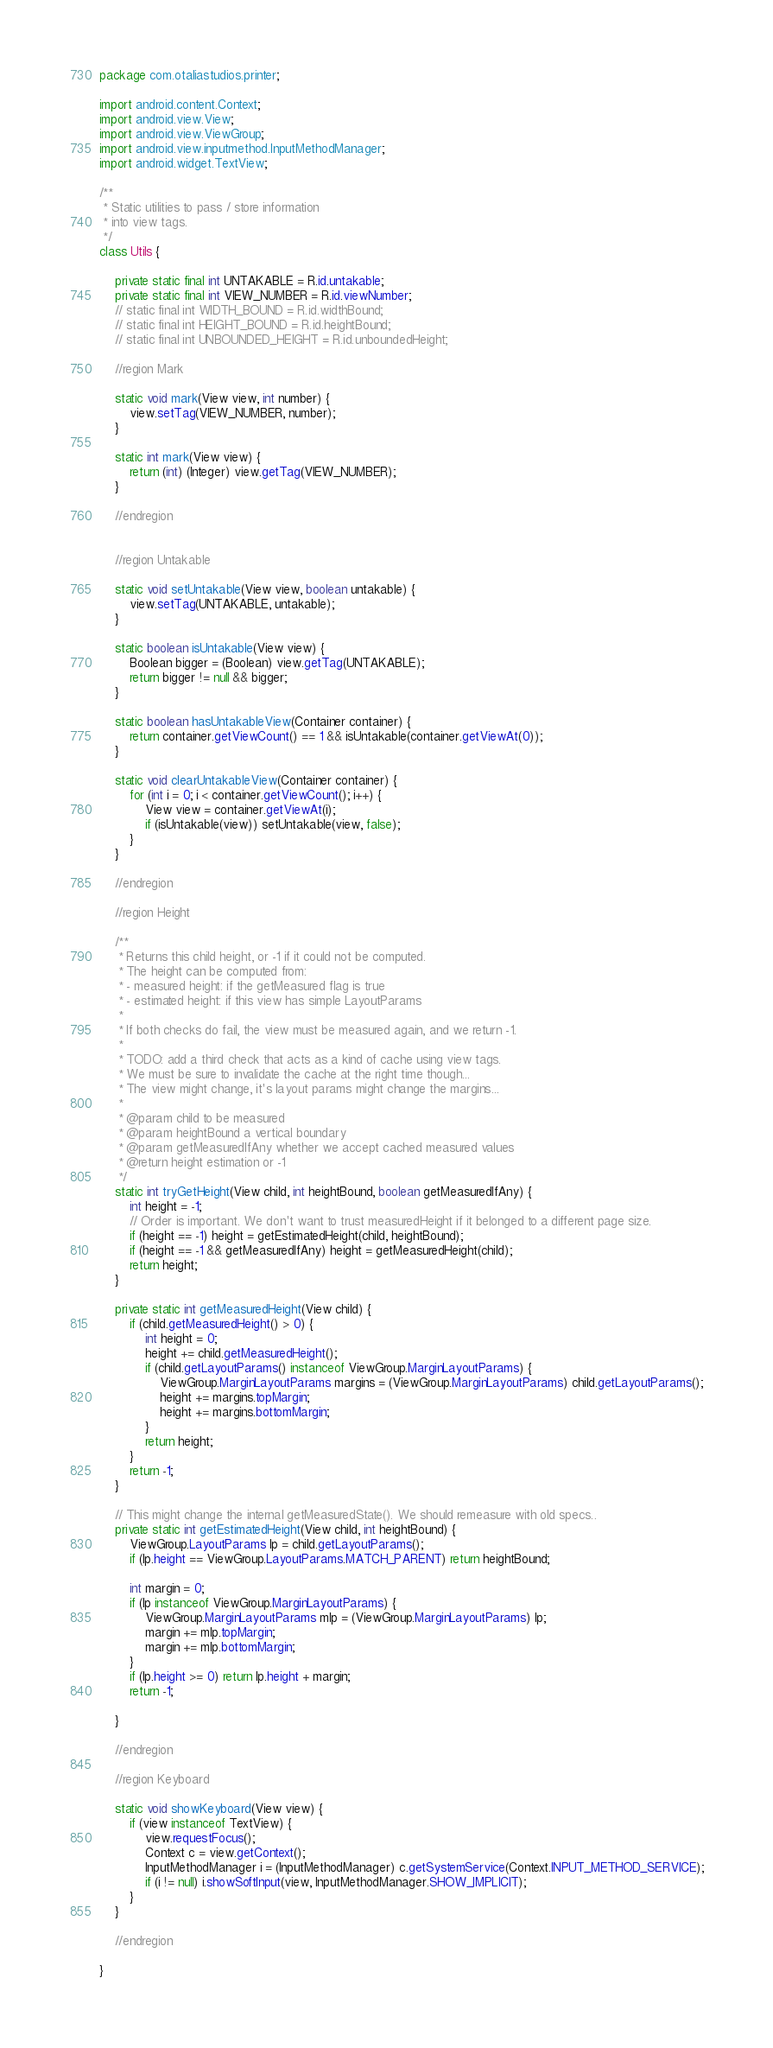<code> <loc_0><loc_0><loc_500><loc_500><_Java_>package com.otaliastudios.printer;

import android.content.Context;
import android.view.View;
import android.view.ViewGroup;
import android.view.inputmethod.InputMethodManager;
import android.widget.TextView;

/**
 * Static utilities to pass / store information
 * into view tags.
 */
class Utils {

    private static final int UNTAKABLE = R.id.untakable;
    private static final int VIEW_NUMBER = R.id.viewNumber;
    // static final int WIDTH_BOUND = R.id.widthBound;
    // static final int HEIGHT_BOUND = R.id.heightBound;
    // static final int UNBOUNDED_HEIGHT = R.id.unboundedHeight;

    //region Mark

    static void mark(View view, int number) {
        view.setTag(VIEW_NUMBER, number);
    }

    static int mark(View view) {
        return (int) (Integer) view.getTag(VIEW_NUMBER);
    }

    //endregion


    //region Untakable

    static void setUntakable(View view, boolean untakable) {
        view.setTag(UNTAKABLE, untakable);
    }

    static boolean isUntakable(View view) {
        Boolean bigger = (Boolean) view.getTag(UNTAKABLE);
        return bigger != null && bigger;
    }

    static boolean hasUntakableView(Container container) {
        return container.getViewCount() == 1 && isUntakable(container.getViewAt(0));
    }

    static void clearUntakableView(Container container) {
        for (int i = 0; i < container.getViewCount(); i++) {
            View view = container.getViewAt(i);
            if (isUntakable(view)) setUntakable(view, false);
        }
    }

    //endregion

    //region Height

    /**
     * Returns this child height, or -1 if it could not be computed.
     * The height can be computed from:
     * - measured height: if the getMeasured flag is true
     * - estimated height: if this view has simple LayoutParams
     *
     * If both checks do fail, the view must be measured again, and we return -1.
     *
     * TODO: add a third check that acts as a kind of cache using view tags.
     * We must be sure to invalidate the cache at the right time though...
     * The view might change, it's layout params might change the margins...
     *
     * @param child to be measured
     * @param heightBound a vertical boundary
     * @param getMeasuredIfAny whether we accept cached measured values
     * @return height estimation or -1
     */
    static int tryGetHeight(View child, int heightBound, boolean getMeasuredIfAny) {
        int height = -1;
        // Order is important. We don't want to trust measuredHeight if it belonged to a different page size.
        if (height == -1) height = getEstimatedHeight(child, heightBound);
        if (height == -1 && getMeasuredIfAny) height = getMeasuredHeight(child);
        return height;
    }

    private static int getMeasuredHeight(View child) {
        if (child.getMeasuredHeight() > 0) {
            int height = 0;
            height += child.getMeasuredHeight();
            if (child.getLayoutParams() instanceof ViewGroup.MarginLayoutParams) {
                ViewGroup.MarginLayoutParams margins = (ViewGroup.MarginLayoutParams) child.getLayoutParams();
                height += margins.topMargin;
                height += margins.bottomMargin;
            }
            return height;
        }
        return -1;
    }

    // This might change the internal getMeasuredState(). We should remeasure with old specs..
    private static int getEstimatedHeight(View child, int heightBound) {
        ViewGroup.LayoutParams lp = child.getLayoutParams();
        if (lp.height == ViewGroup.LayoutParams.MATCH_PARENT) return heightBound;

        int margin = 0;
        if (lp instanceof ViewGroup.MarginLayoutParams) {
            ViewGroup.MarginLayoutParams mlp = (ViewGroup.MarginLayoutParams) lp;
            margin += mlp.topMargin;
            margin += mlp.bottomMargin;
        }
        if (lp.height >= 0) return lp.height + margin;
        return -1;

    }

    //endregion

    //region Keyboard

    static void showKeyboard(View view) {
        if (view instanceof TextView) {
            view.requestFocus();
            Context c = view.getContext();
            InputMethodManager i = (InputMethodManager) c.getSystemService(Context.INPUT_METHOD_SERVICE);
            if (i != null) i.showSoftInput(view, InputMethodManager.SHOW_IMPLICIT);
        }
    }

    //endregion

}
</code> 